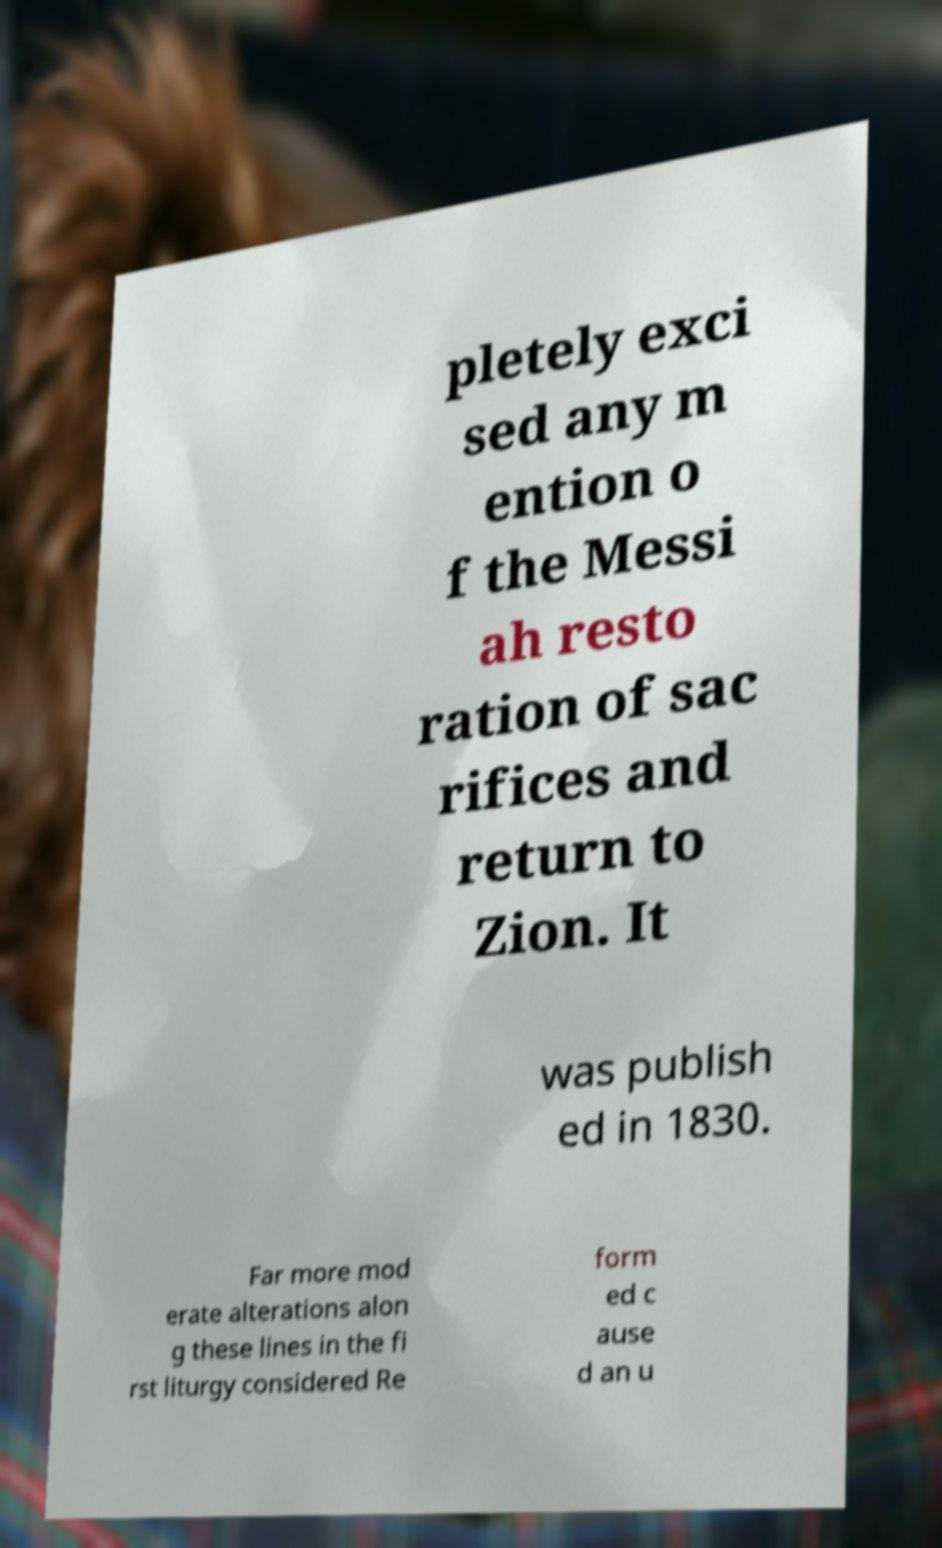Please identify and transcribe the text found in this image. pletely exci sed any m ention o f the Messi ah resto ration of sac rifices and return to Zion. It was publish ed in 1830. Far more mod erate alterations alon g these lines in the fi rst liturgy considered Re form ed c ause d an u 